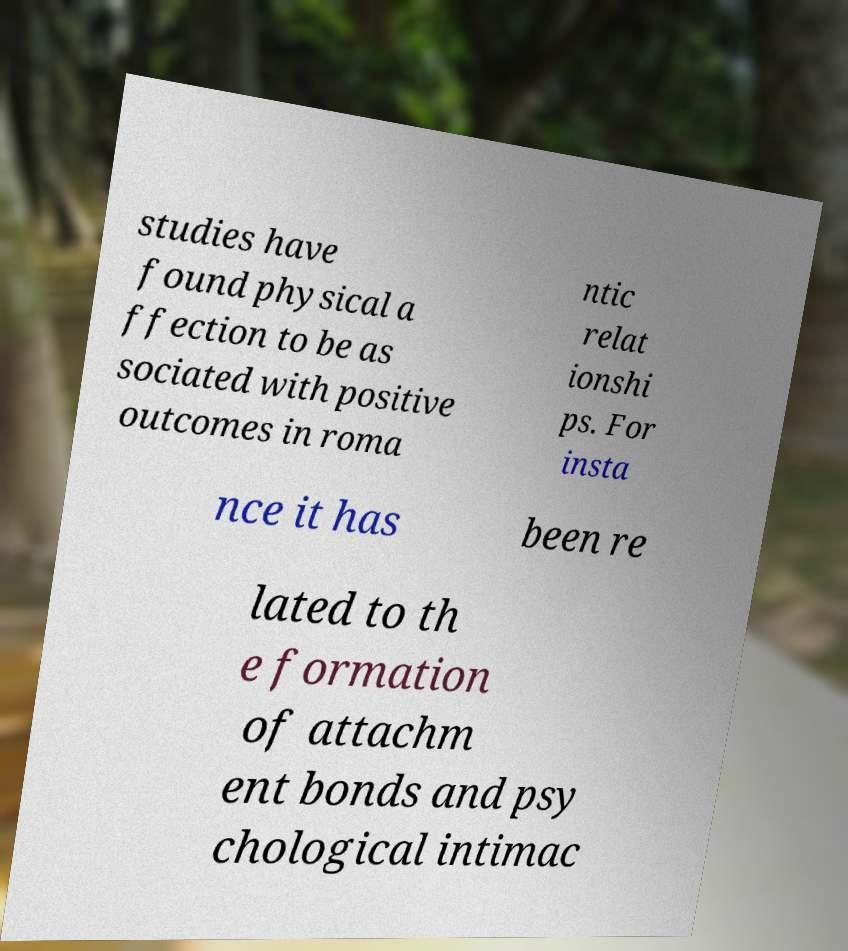I need the written content from this picture converted into text. Can you do that? studies have found physical a ffection to be as sociated with positive outcomes in roma ntic relat ionshi ps. For insta nce it has been re lated to th e formation of attachm ent bonds and psy chological intimac 